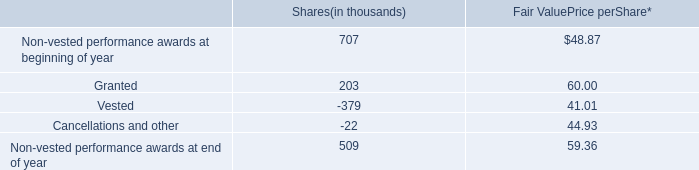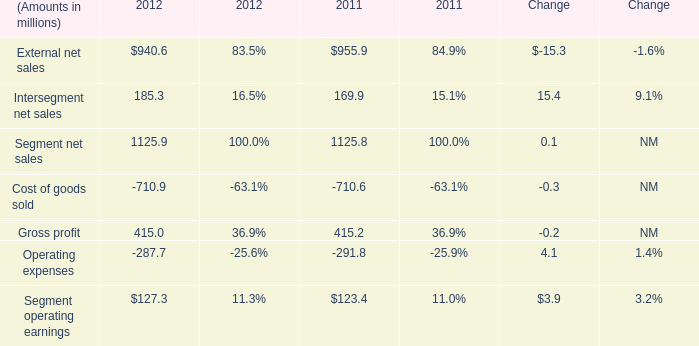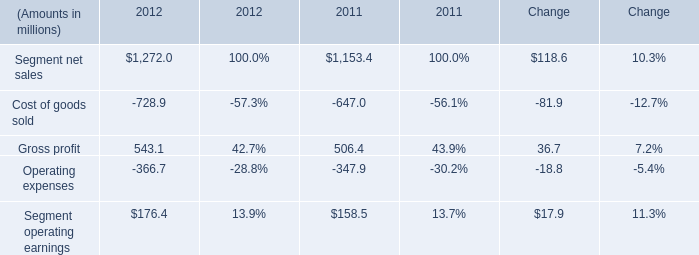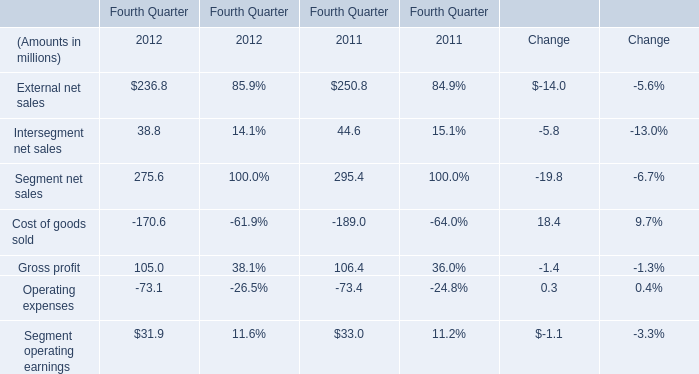What was the average value of the Segment net sales and 5 Cost of goods sold in the years where External net sales is positive? (in million) 
Computations: ((295.4 - 189.0) / 2)
Answer: 53.2. 